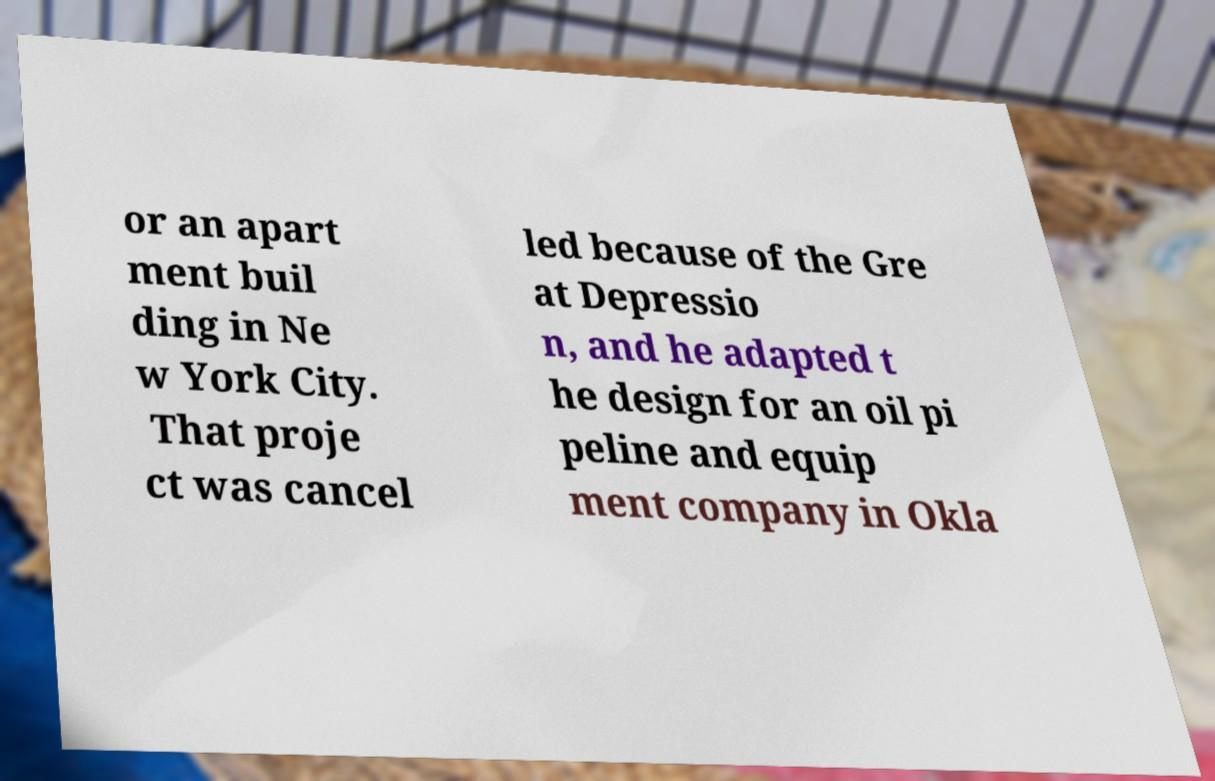Could you extract and type out the text from this image? or an apart ment buil ding in Ne w York City. That proje ct was cancel led because of the Gre at Depressio n, and he adapted t he design for an oil pi peline and equip ment company in Okla 